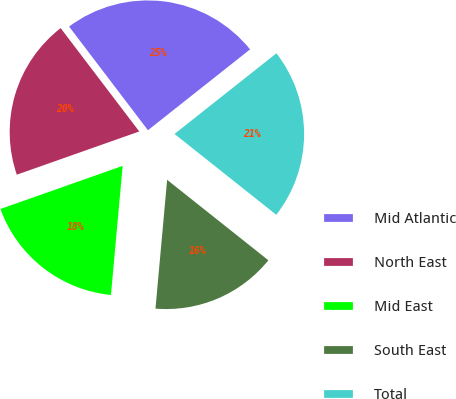<chart> <loc_0><loc_0><loc_500><loc_500><pie_chart><fcel>Mid Atlantic<fcel>North East<fcel>Mid East<fcel>South East<fcel>Total<nl><fcel>24.69%<fcel>20.05%<fcel>18.16%<fcel>15.75%<fcel>21.34%<nl></chart> 